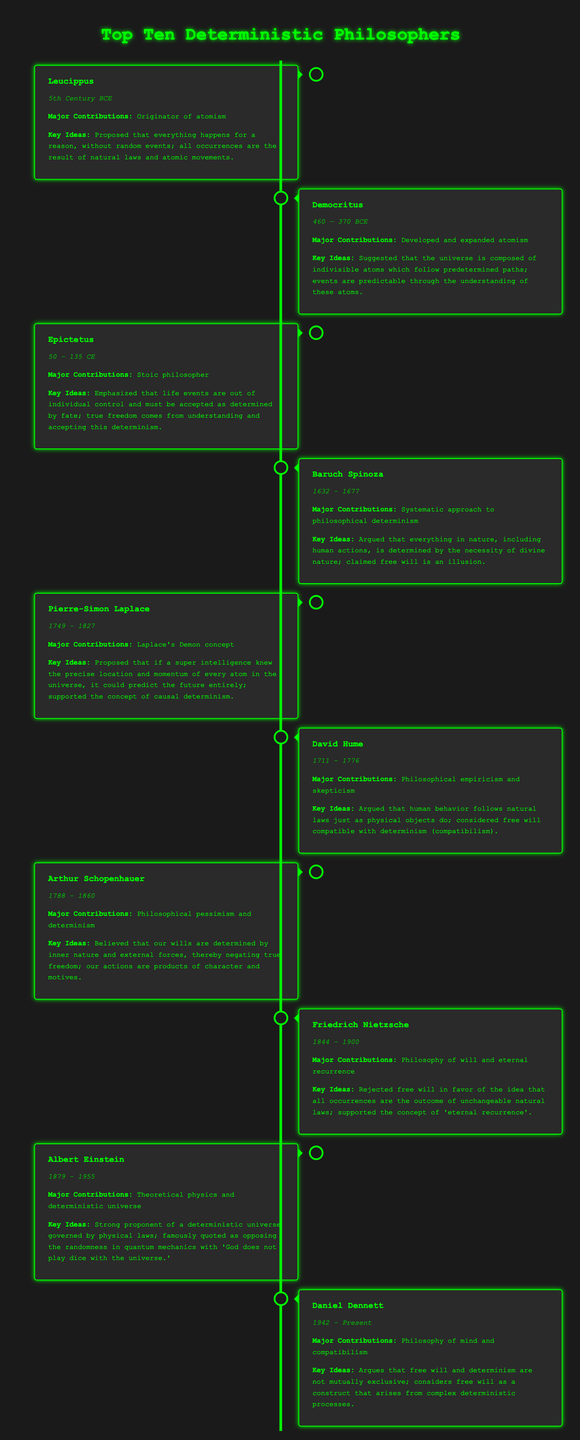What is the name of the first philosopher listed? The first philosopher listed is Leucippus, noted for being the originator of atomism.
Answer: Leucippus In which century did Democritus live? Democritus lived from 460 to 370 BCE, which places him in the 5th century BCE.
Answer: 5th Century BCE What key idea does Baruch Spinoza emphasize? Baruch Spinoza emphasized that free will is an illusion, arguing everything in nature is determined by the necessity of divine nature.
Answer: Free will is an illusion What year did Albert Einstein pass away? Albert Einstein was born in 1879 and passed away in 1955, marking the end of his life.
Answer: 1955 What major contribution is attributed to Daniel Dennett? Daniel Dennett is recognized for his contributions to the philosophy of mind and the concept of compatibilism.
Answer: Philosophy of mind and compatibilism Which philosopher proposed the concept of "Laplace's Demon"? Pierre-Simon Laplace proposed the concept of "Laplace's Demon," which aligns with the idea of causal determinism.
Answer: Pierre-Simon Laplace What is the timeline date for Friedrich Nietzsche? Friedrich Nietzsche lived from 1844 to 1900.
Answer: 1844 – 1900 According to Epictetus, what offers true freedom? True freedom comes from understanding and accepting determinism, which Epictetus highlights in his teachings.
Answer: Understanding and accepting determinism What philosophical stance does David Hume represent? David Hume is known for philosophical empiricism and skepticism, articulating views on human behavior and natural laws.
Answer: Philosophical empiricism and skepticism 